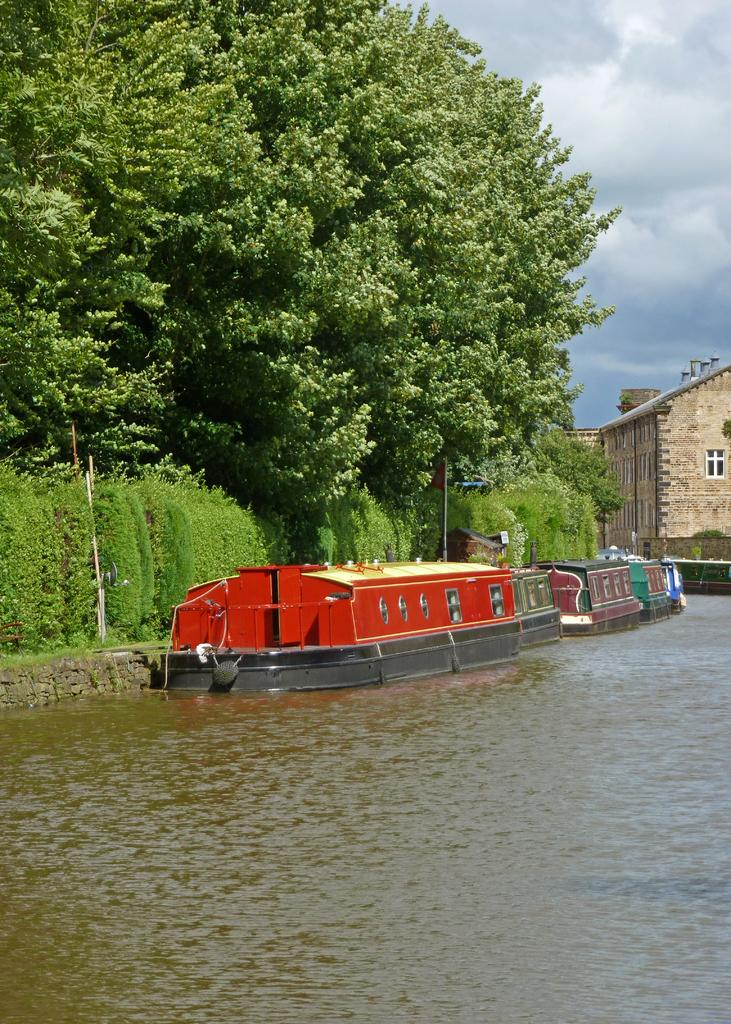What type of vegetation can be seen in the image? There are trees in the image. What is in the water in the image? There are boats in the water. What type of structures are present in the image? There are buildings in the image. How would you describe the sky in the image? The sky is cloudy in the image. Which actor is performing on the territory shown in the image? There is no actor or performance present in the image; it features trees, boats, buildings, and a cloudy sky. How many territories are visible in the image? The term "territory" is not applicable to the image, as it does not depict any specific geographical area or boundary. 